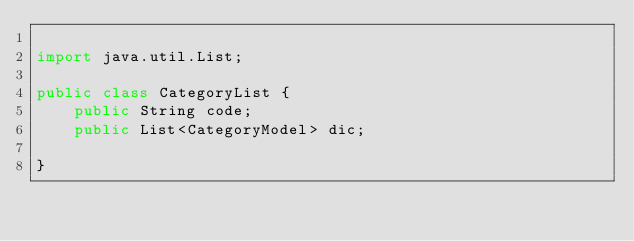<code> <loc_0><loc_0><loc_500><loc_500><_Java_>
import java.util.List;

public class CategoryList {
    public String code;
    public List<CategoryModel> dic;

}
</code> 